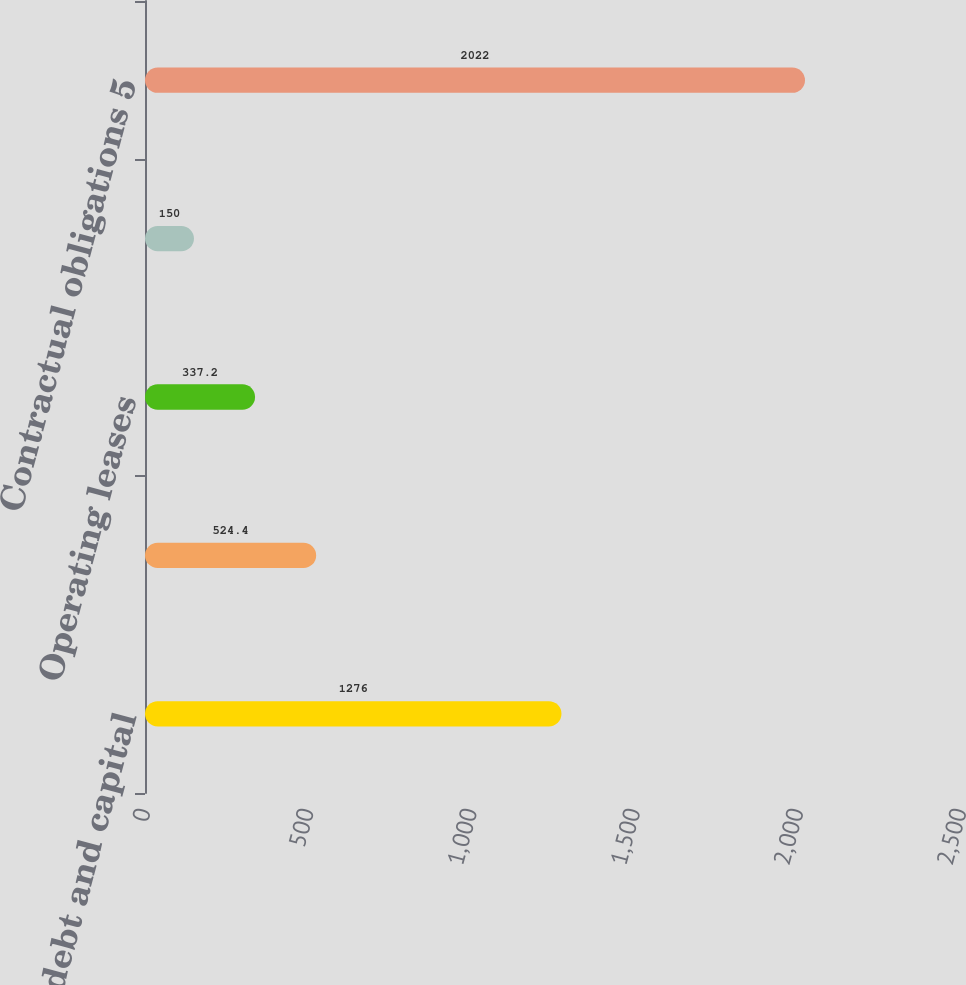<chart> <loc_0><loc_0><loc_500><loc_500><bar_chart><fcel>Long-term debt and capital<fcel>Interest on short- and<fcel>Operating leases<fcel>Purchase obligations 3<fcel>Contractual obligations 5<nl><fcel>1276<fcel>524.4<fcel>337.2<fcel>150<fcel>2022<nl></chart> 